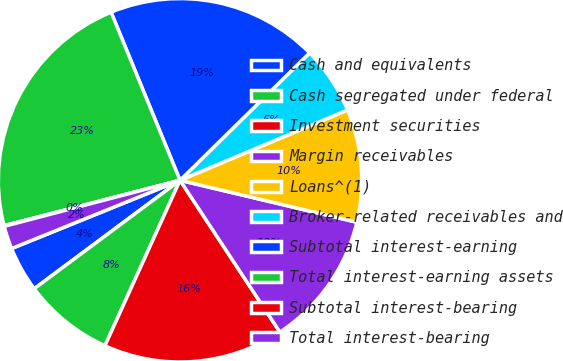Convert chart to OTSL. <chart><loc_0><loc_0><loc_500><loc_500><pie_chart><fcel>Cash and equivalents<fcel>Cash segregated under federal<fcel>Investment securities<fcel>Margin receivables<fcel>Loans^(1)<fcel>Broker-related receivables and<fcel>Subtotal interest-earning<fcel>Total interest-earning assets<fcel>Subtotal interest-bearing<fcel>Total interest-bearing<nl><fcel>4.05%<fcel>8.04%<fcel>16.04%<fcel>12.03%<fcel>10.03%<fcel>6.04%<fcel>18.83%<fcel>22.82%<fcel>0.06%<fcel>2.05%<nl></chart> 